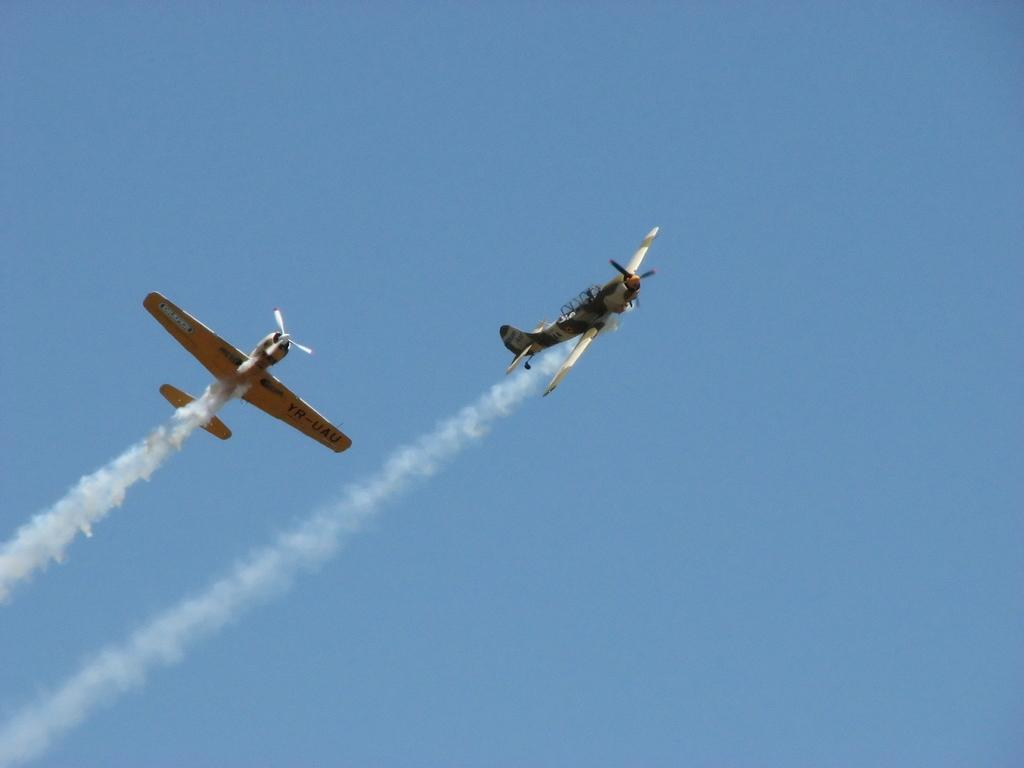How many airplanes are visible in the image? There are two airplanes in the image. Where are the airplanes located? The airplanes are in the sky. What type of cobweb can be seen in the image? There is no cobweb present in the image. What industry is depicted in the image? The image does not depict any specific industry; it features two airplanes in the sky. 